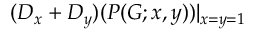Convert formula to latex. <formula><loc_0><loc_0><loc_500><loc_500>( D _ { x } + D _ { y } ) ( P ( G ; x , y ) ) | _ { x = y = 1 }</formula> 